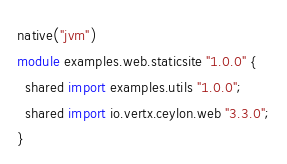Convert code to text. <code><loc_0><loc_0><loc_500><loc_500><_Ceylon_>native("jvm")
module examples.web.staticsite "1.0.0" {
  shared import examples.utils "1.0.0";
  shared import io.vertx.ceylon.web "3.3.0";
}
</code> 